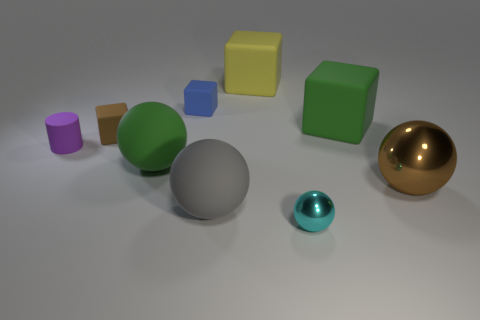Subtract 1 spheres. How many spheres are left? 3 Subtract all cubes. How many objects are left? 5 Add 4 tiny green balls. How many tiny green balls exist? 4 Subtract 1 brown cubes. How many objects are left? 8 Subtract all gray rubber objects. Subtract all green spheres. How many objects are left? 7 Add 7 green blocks. How many green blocks are left? 8 